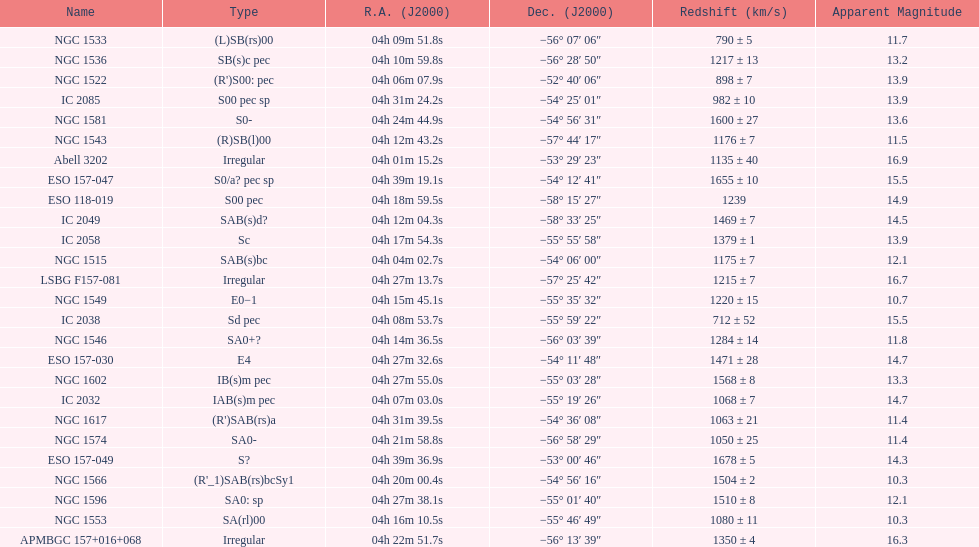Name the member with the highest apparent magnitude. Abell 3202. 